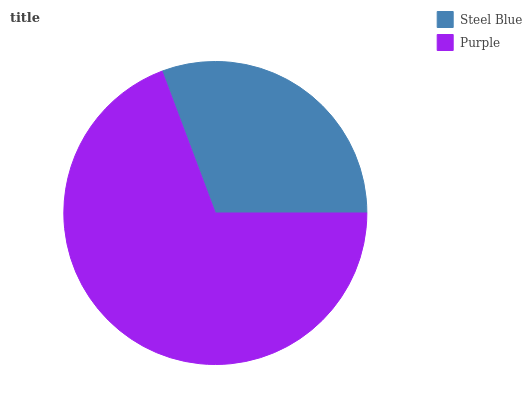Is Steel Blue the minimum?
Answer yes or no. Yes. Is Purple the maximum?
Answer yes or no. Yes. Is Purple the minimum?
Answer yes or no. No. Is Purple greater than Steel Blue?
Answer yes or no. Yes. Is Steel Blue less than Purple?
Answer yes or no. Yes. Is Steel Blue greater than Purple?
Answer yes or no. No. Is Purple less than Steel Blue?
Answer yes or no. No. Is Purple the high median?
Answer yes or no. Yes. Is Steel Blue the low median?
Answer yes or no. Yes. Is Steel Blue the high median?
Answer yes or no. No. Is Purple the low median?
Answer yes or no. No. 